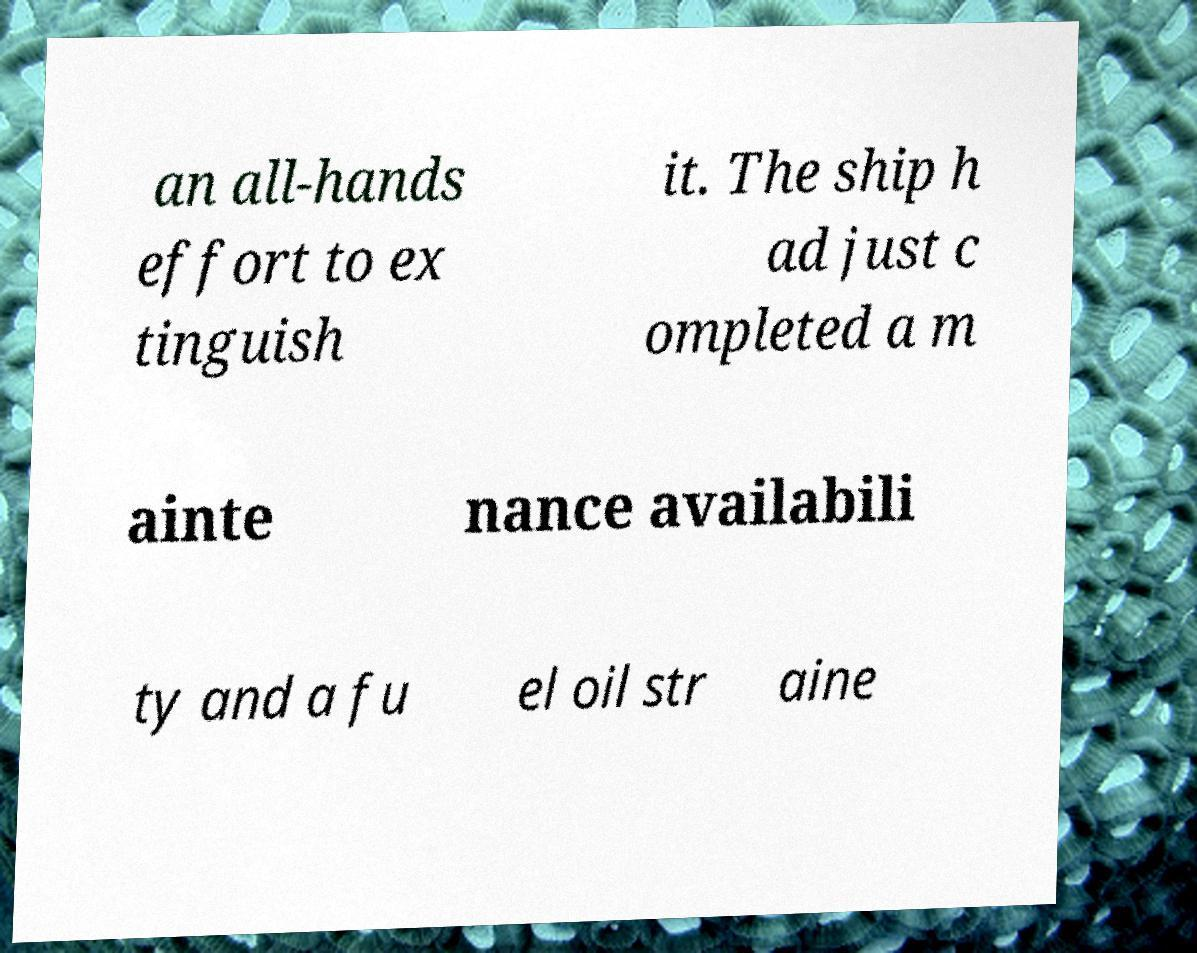Please read and relay the text visible in this image. What does it say? an all-hands effort to ex tinguish it. The ship h ad just c ompleted a m ainte nance availabili ty and a fu el oil str aine 